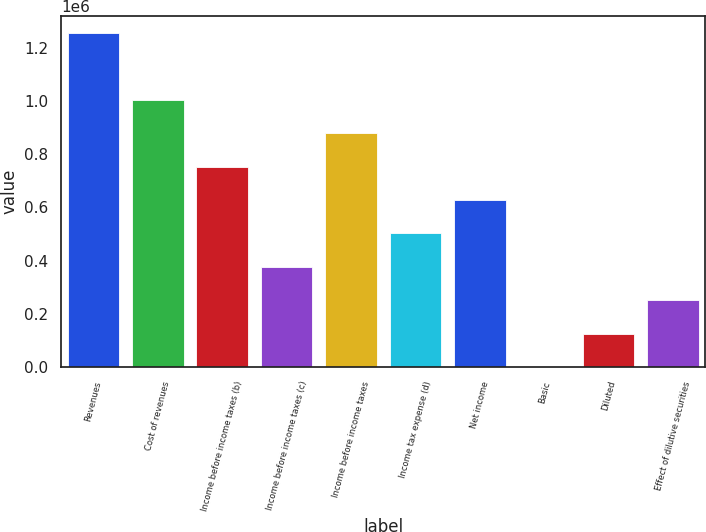Convert chart to OTSL. <chart><loc_0><loc_0><loc_500><loc_500><bar_chart><fcel>Revenues<fcel>Cost of revenues<fcel>Income before income taxes (b)<fcel>Income before income taxes (c)<fcel>Income before income taxes<fcel>Income tax expense (d)<fcel>Net income<fcel>Basic<fcel>Diluted<fcel>Effect of dilutive securities<nl><fcel>1.25499e+06<fcel>1.00399e+06<fcel>752993<fcel>376497<fcel>878492<fcel>501996<fcel>627495<fcel>0.11<fcel>125499<fcel>250998<nl></chart> 